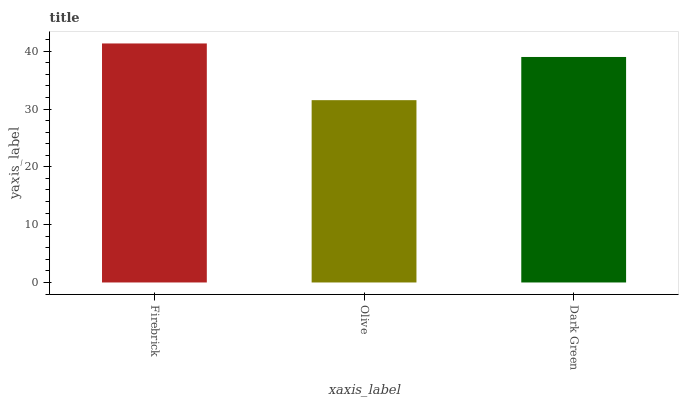Is Olive the minimum?
Answer yes or no. Yes. Is Firebrick the maximum?
Answer yes or no. Yes. Is Dark Green the minimum?
Answer yes or no. No. Is Dark Green the maximum?
Answer yes or no. No. Is Dark Green greater than Olive?
Answer yes or no. Yes. Is Olive less than Dark Green?
Answer yes or no. Yes. Is Olive greater than Dark Green?
Answer yes or no. No. Is Dark Green less than Olive?
Answer yes or no. No. Is Dark Green the high median?
Answer yes or no. Yes. Is Dark Green the low median?
Answer yes or no. Yes. Is Olive the high median?
Answer yes or no. No. Is Firebrick the low median?
Answer yes or no. No. 